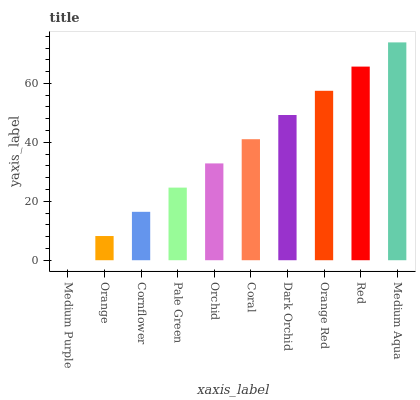Is Medium Purple the minimum?
Answer yes or no. Yes. Is Medium Aqua the maximum?
Answer yes or no. Yes. Is Orange the minimum?
Answer yes or no. No. Is Orange the maximum?
Answer yes or no. No. Is Orange greater than Medium Purple?
Answer yes or no. Yes. Is Medium Purple less than Orange?
Answer yes or no. Yes. Is Medium Purple greater than Orange?
Answer yes or no. No. Is Orange less than Medium Purple?
Answer yes or no. No. Is Coral the high median?
Answer yes or no. Yes. Is Orchid the low median?
Answer yes or no. Yes. Is Orange the high median?
Answer yes or no. No. Is Medium Purple the low median?
Answer yes or no. No. 